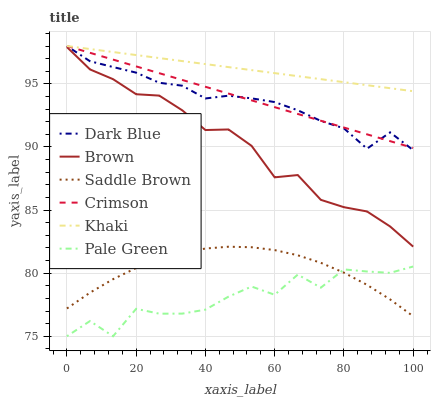Does Pale Green have the minimum area under the curve?
Answer yes or no. Yes. Does Khaki have the maximum area under the curve?
Answer yes or no. Yes. Does Dark Blue have the minimum area under the curve?
Answer yes or no. No. Does Dark Blue have the maximum area under the curve?
Answer yes or no. No. Is Khaki the smoothest?
Answer yes or no. Yes. Is Pale Green the roughest?
Answer yes or no. Yes. Is Dark Blue the smoothest?
Answer yes or no. No. Is Dark Blue the roughest?
Answer yes or no. No. Does Pale Green have the lowest value?
Answer yes or no. Yes. Does Dark Blue have the lowest value?
Answer yes or no. No. Does Crimson have the highest value?
Answer yes or no. Yes. Does Pale Green have the highest value?
Answer yes or no. No. Is Pale Green less than Crimson?
Answer yes or no. Yes. Is Crimson greater than Saddle Brown?
Answer yes or no. Yes. Does Saddle Brown intersect Pale Green?
Answer yes or no. Yes. Is Saddle Brown less than Pale Green?
Answer yes or no. No. Is Saddle Brown greater than Pale Green?
Answer yes or no. No. Does Pale Green intersect Crimson?
Answer yes or no. No. 